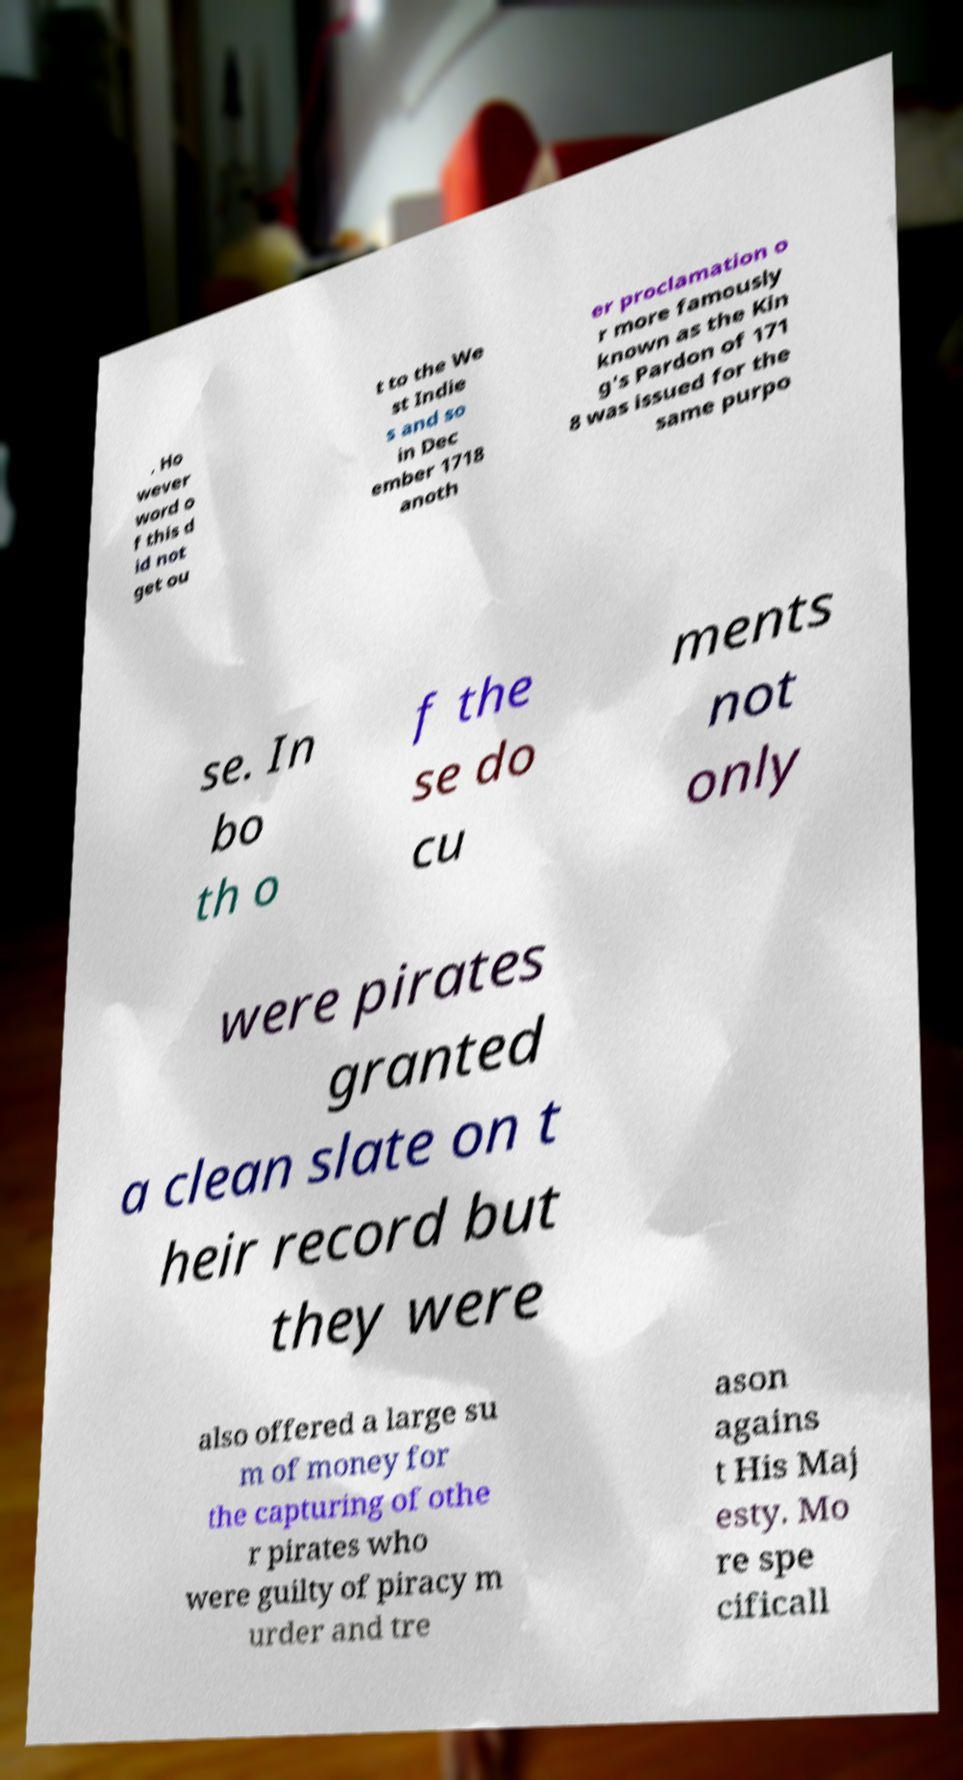There's text embedded in this image that I need extracted. Can you transcribe it verbatim? . Ho wever word o f this d id not get ou t to the We st Indie s and so in Dec ember 1718 anoth er proclamation o r more famously known as the Kin g's Pardon of 171 8 was issued for the same purpo se. In bo th o f the se do cu ments not only were pirates granted a clean slate on t heir record but they were also offered a large su m of money for the capturing of othe r pirates who were guilty of piracy m urder and tre ason agains t His Maj esty. Mo re spe cificall 